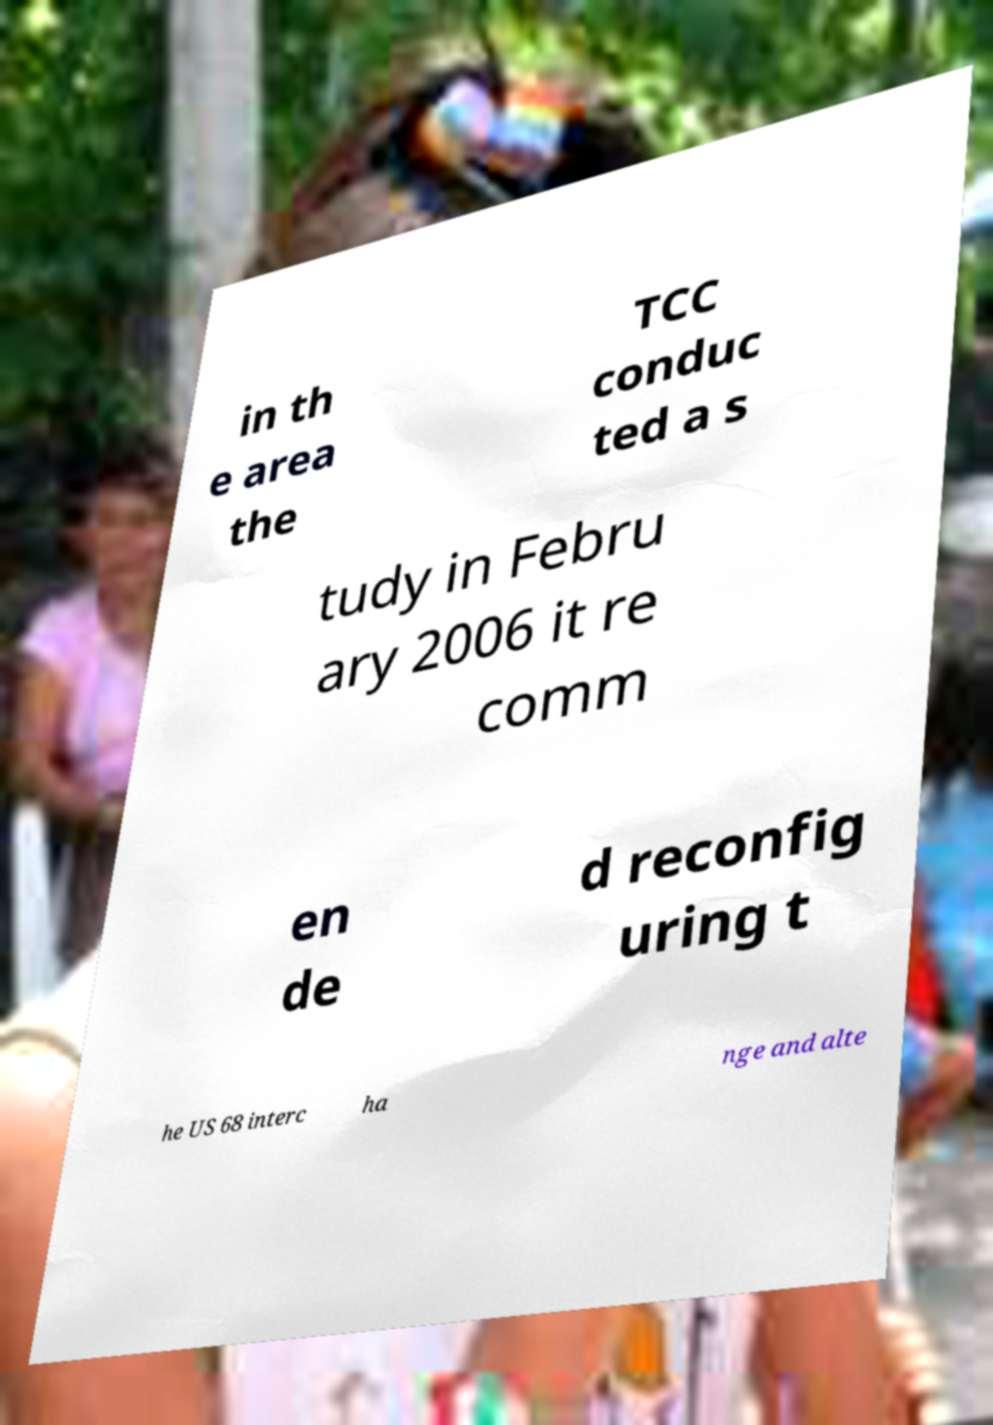Can you accurately transcribe the text from the provided image for me? in th e area the TCC conduc ted a s tudy in Febru ary 2006 it re comm en de d reconfig uring t he US 68 interc ha nge and alte 